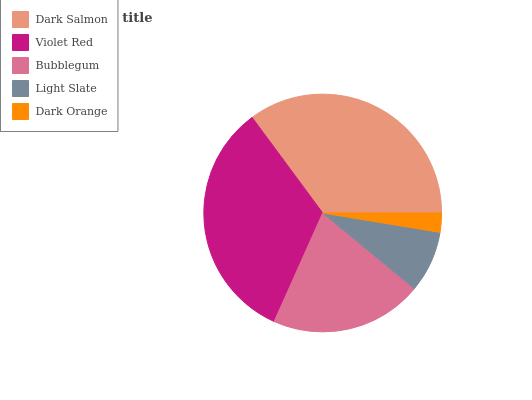Is Dark Orange the minimum?
Answer yes or no. Yes. Is Dark Salmon the maximum?
Answer yes or no. Yes. Is Violet Red the minimum?
Answer yes or no. No. Is Violet Red the maximum?
Answer yes or no. No. Is Dark Salmon greater than Violet Red?
Answer yes or no. Yes. Is Violet Red less than Dark Salmon?
Answer yes or no. Yes. Is Violet Red greater than Dark Salmon?
Answer yes or no. No. Is Dark Salmon less than Violet Red?
Answer yes or no. No. Is Bubblegum the high median?
Answer yes or no. Yes. Is Bubblegum the low median?
Answer yes or no. Yes. Is Dark Salmon the high median?
Answer yes or no. No. Is Violet Red the low median?
Answer yes or no. No. 